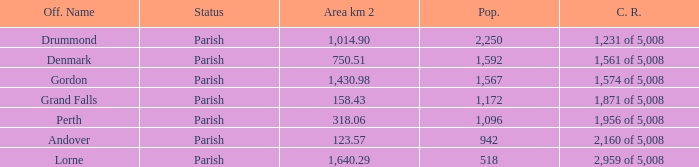Which parish has an area of 750.51? Denmark. 